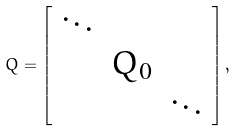<formula> <loc_0><loc_0><loc_500><loc_500>Q = \left [ \begin{array} { c c c } \ddots & & \\ & Q _ { 0 } & \\ & & \ddots \end{array} \right ] ,</formula> 